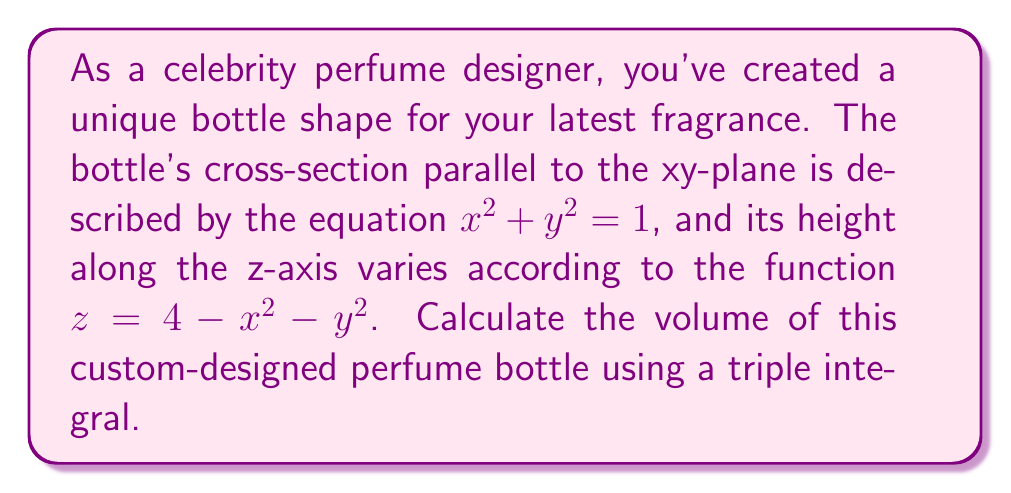Could you help me with this problem? To calculate the volume of this custom-designed perfume bottle, we need to set up and evaluate a triple integral. Let's approach this step-by-step:

1) First, we need to identify the limits of integration. The base of the bottle is a circle in the xy-plane described by $x^2 + y^2 = 1$. The height of the bottle is given by $z = 4 - x^2 - y^2$.

2) We can set up the triple integral in cylindrical coordinates $(r, \theta, z)$, which will simplify our calculations due to the circular base.

3) The limits of integration will be:
   $0 \leq r \leq 1$ (radius of the base)
   $0 \leq \theta \leq 2\pi$ (full circular base)
   $0 \leq z \leq 4 - r^2$ (height of the bottle)

4) The volume integral in cylindrical coordinates is:

   $$V = \int_0^{2\pi} \int_0^1 \int_0^{4-r^2} r \, dz \, dr \, d\theta$$

5) Let's solve the integral from inside out:

   $$V = \int_0^{2\pi} \int_0^1 r [z]_0^{4-r^2} \, dr \, d\theta$$
   $$= \int_0^{2\pi} \int_0^1 r (4-r^2) \, dr \, d\theta$$

6) Now, let's solve the inner integral:

   $$= \int_0^{2\pi} \left[2r^2 - \frac{r^4}{4}\right]_0^1 \, d\theta$$
   $$= \int_0^{2\pi} \left(2 - \frac{1}{4}\right) \, d\theta$$
   $$= \int_0^{2\pi} \frac{7}{4} \, d\theta$$

7) Finally, we can solve the outer integral:

   $$= \frac{7}{4} [{\theta}]_0^{2\pi}$$
   $$= \frac{7}{4} (2\pi - 0)$$
   $$= \frac{7\pi}{2}$$

Therefore, the volume of the custom-designed perfume bottle is $\frac{7\pi}{2}$ cubic units.
Answer: $\frac{7\pi}{2}$ cubic units 